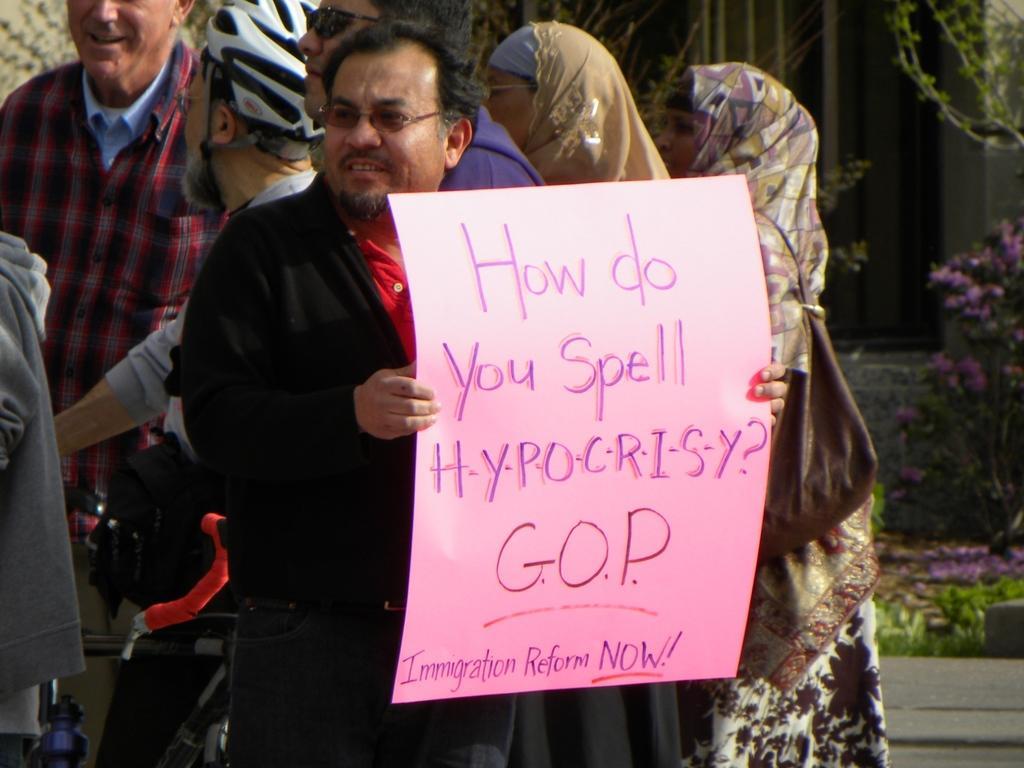Describe this image in one or two sentences. In this image, we can see people and some are wearing scarves and some are wearing glasses, one of them is holding a paper with some text. In the background, there are plants and we can see a bicycle. 